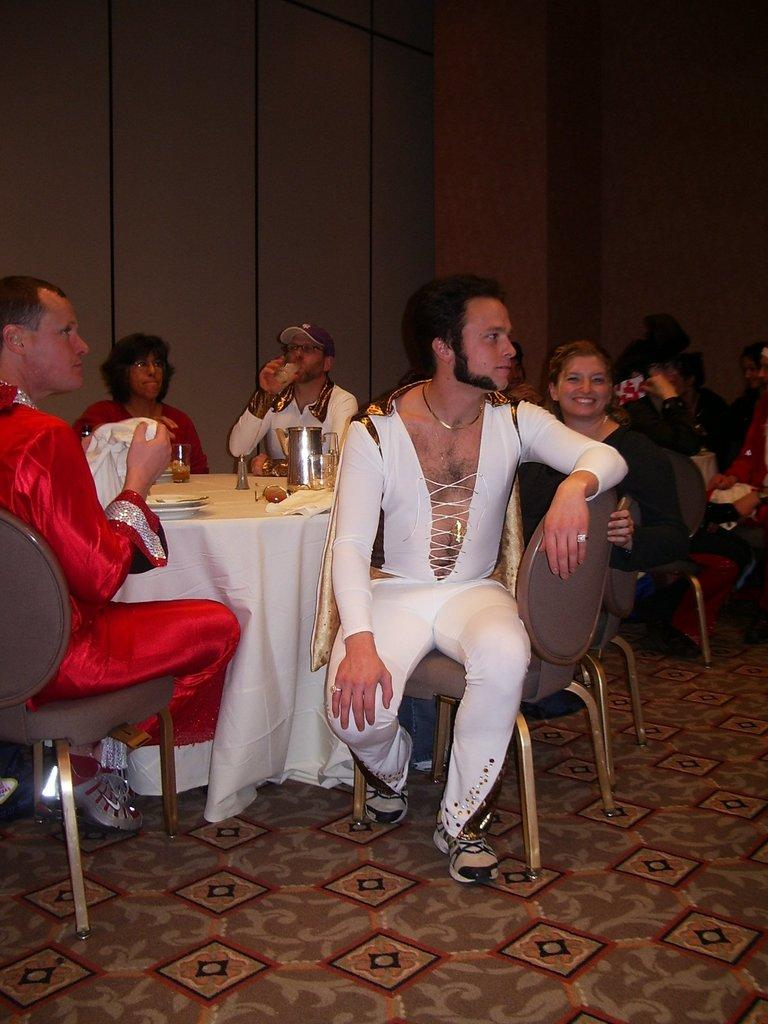What are the people in the image doing? The people in the image are sitting on chairs around a table. What can be found on the table? There is a jar, food, and glasses on the table. What is the background of the image? There is a wall visible in the image. What type of bread can be seen on the edge of the table in the image? There is no bread visible on the edge of the table in the image. 